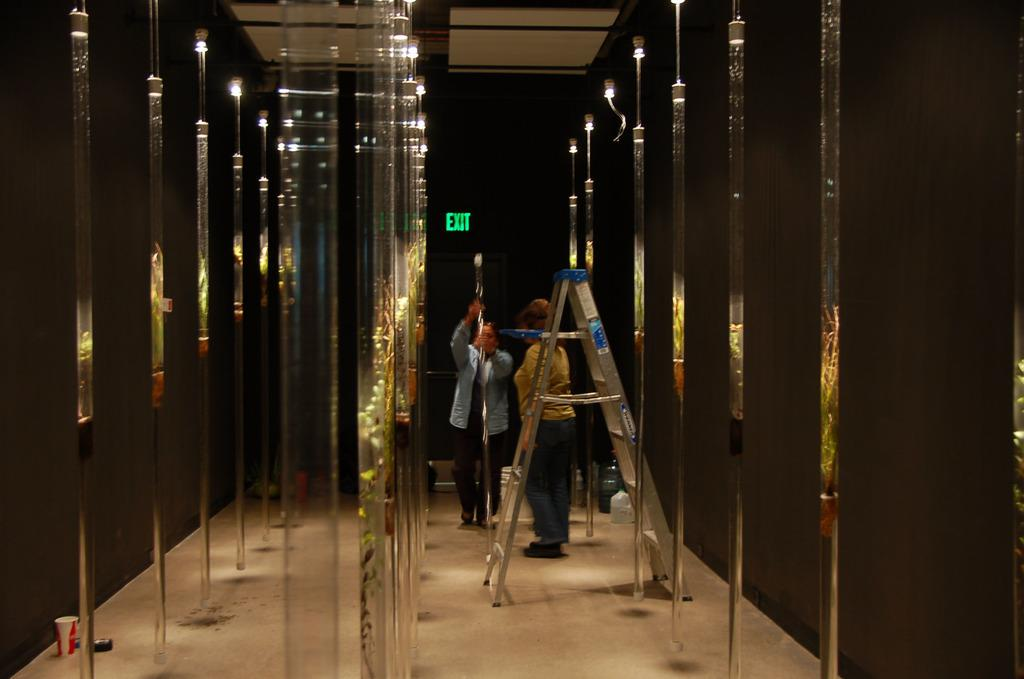<image>
Create a compact narrative representing the image presented. Two people stand in a hallway below a green exit sign. 